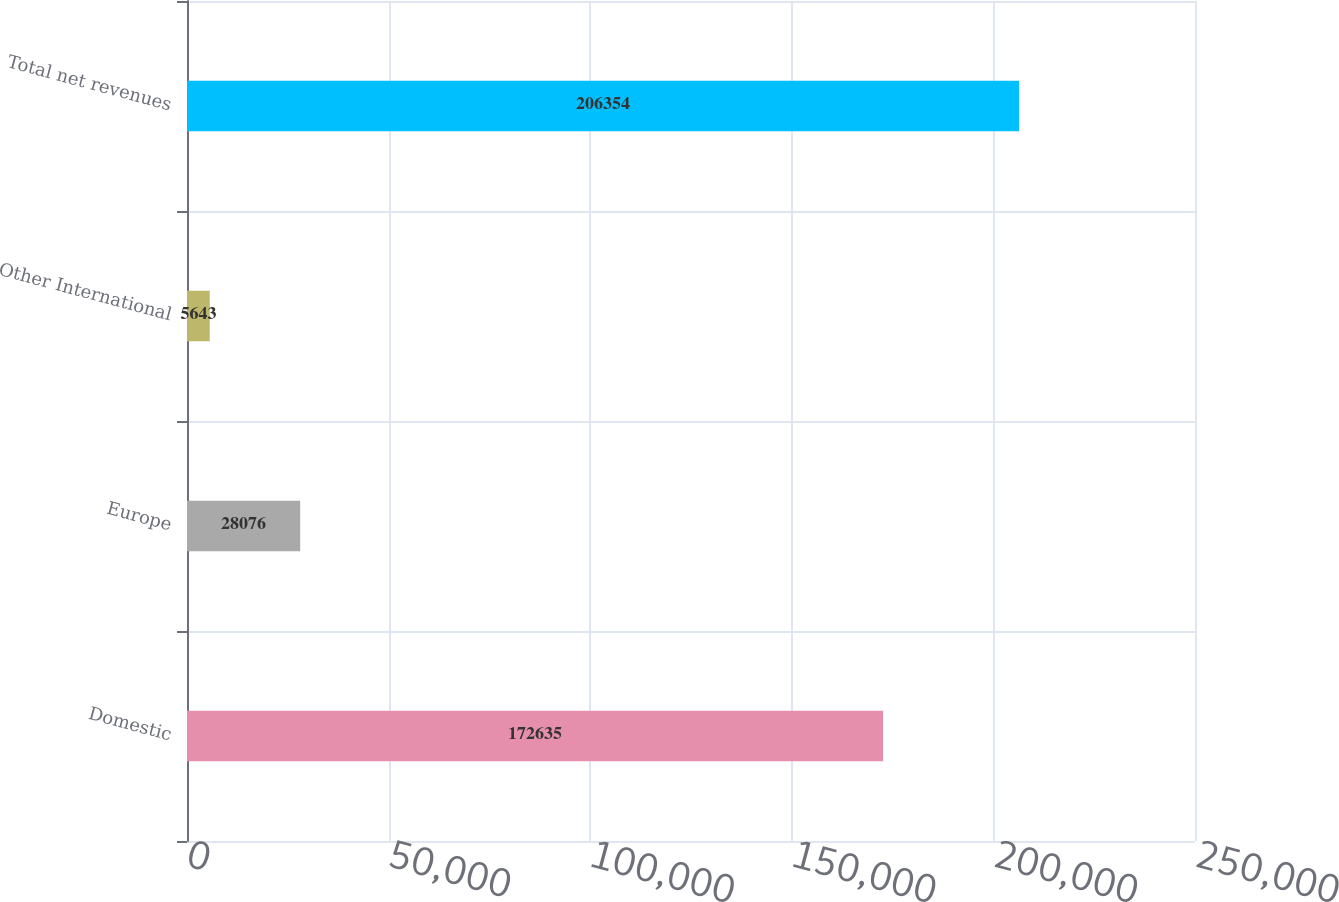Convert chart. <chart><loc_0><loc_0><loc_500><loc_500><bar_chart><fcel>Domestic<fcel>Europe<fcel>Other International<fcel>Total net revenues<nl><fcel>172635<fcel>28076<fcel>5643<fcel>206354<nl></chart> 